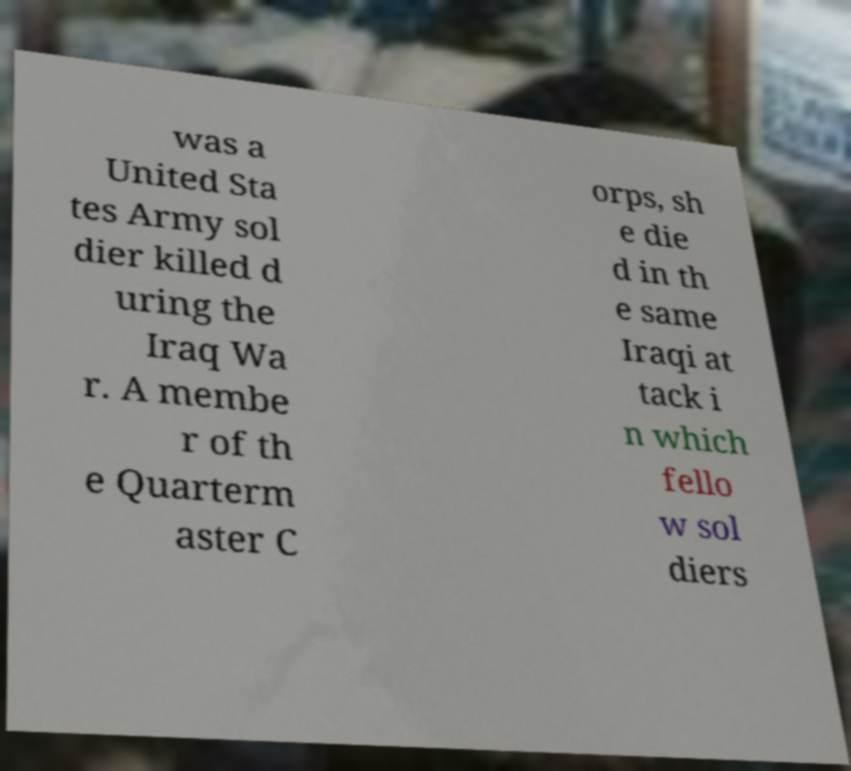Can you accurately transcribe the text from the provided image for me? was a United Sta tes Army sol dier killed d uring the Iraq Wa r. A membe r of th e Quarterm aster C orps, sh e die d in th e same Iraqi at tack i n which fello w sol diers 